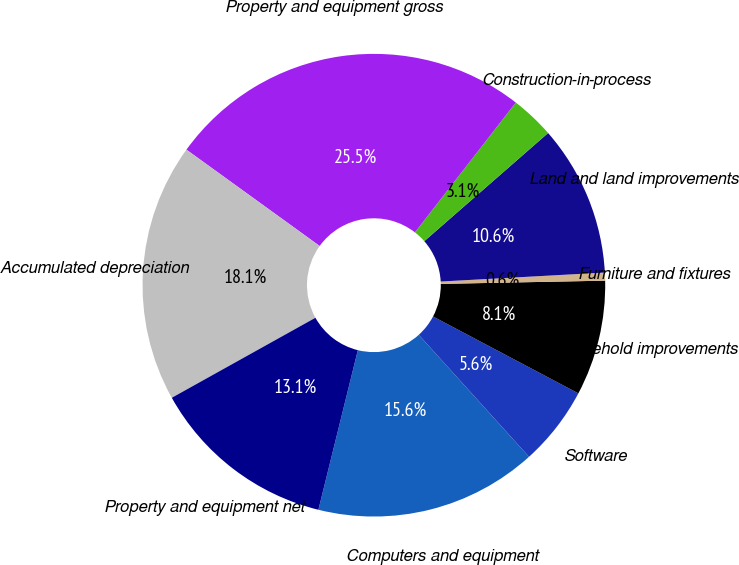<chart> <loc_0><loc_0><loc_500><loc_500><pie_chart><fcel>Computers and equipment<fcel>Software<fcel>Leasehold improvements<fcel>Furniture and fixtures<fcel>Land and land improvements<fcel>Construction-in-process<fcel>Property and equipment gross<fcel>Accumulated depreciation<fcel>Property and equipment net<nl><fcel>15.56%<fcel>5.56%<fcel>8.06%<fcel>0.56%<fcel>10.56%<fcel>3.06%<fcel>25.56%<fcel>18.06%<fcel>13.06%<nl></chart> 